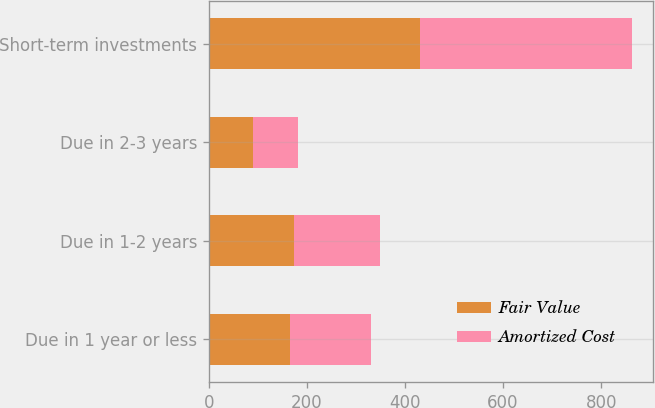Convert chart to OTSL. <chart><loc_0><loc_0><loc_500><loc_500><stacked_bar_chart><ecel><fcel>Due in 1 year or less<fcel>Due in 1-2 years<fcel>Due in 2-3 years<fcel>Short-term investments<nl><fcel>Fair Value<fcel>165<fcel>174<fcel>91<fcel>430<nl><fcel>Amortized Cost<fcel>165<fcel>176<fcel>91<fcel>432<nl></chart> 